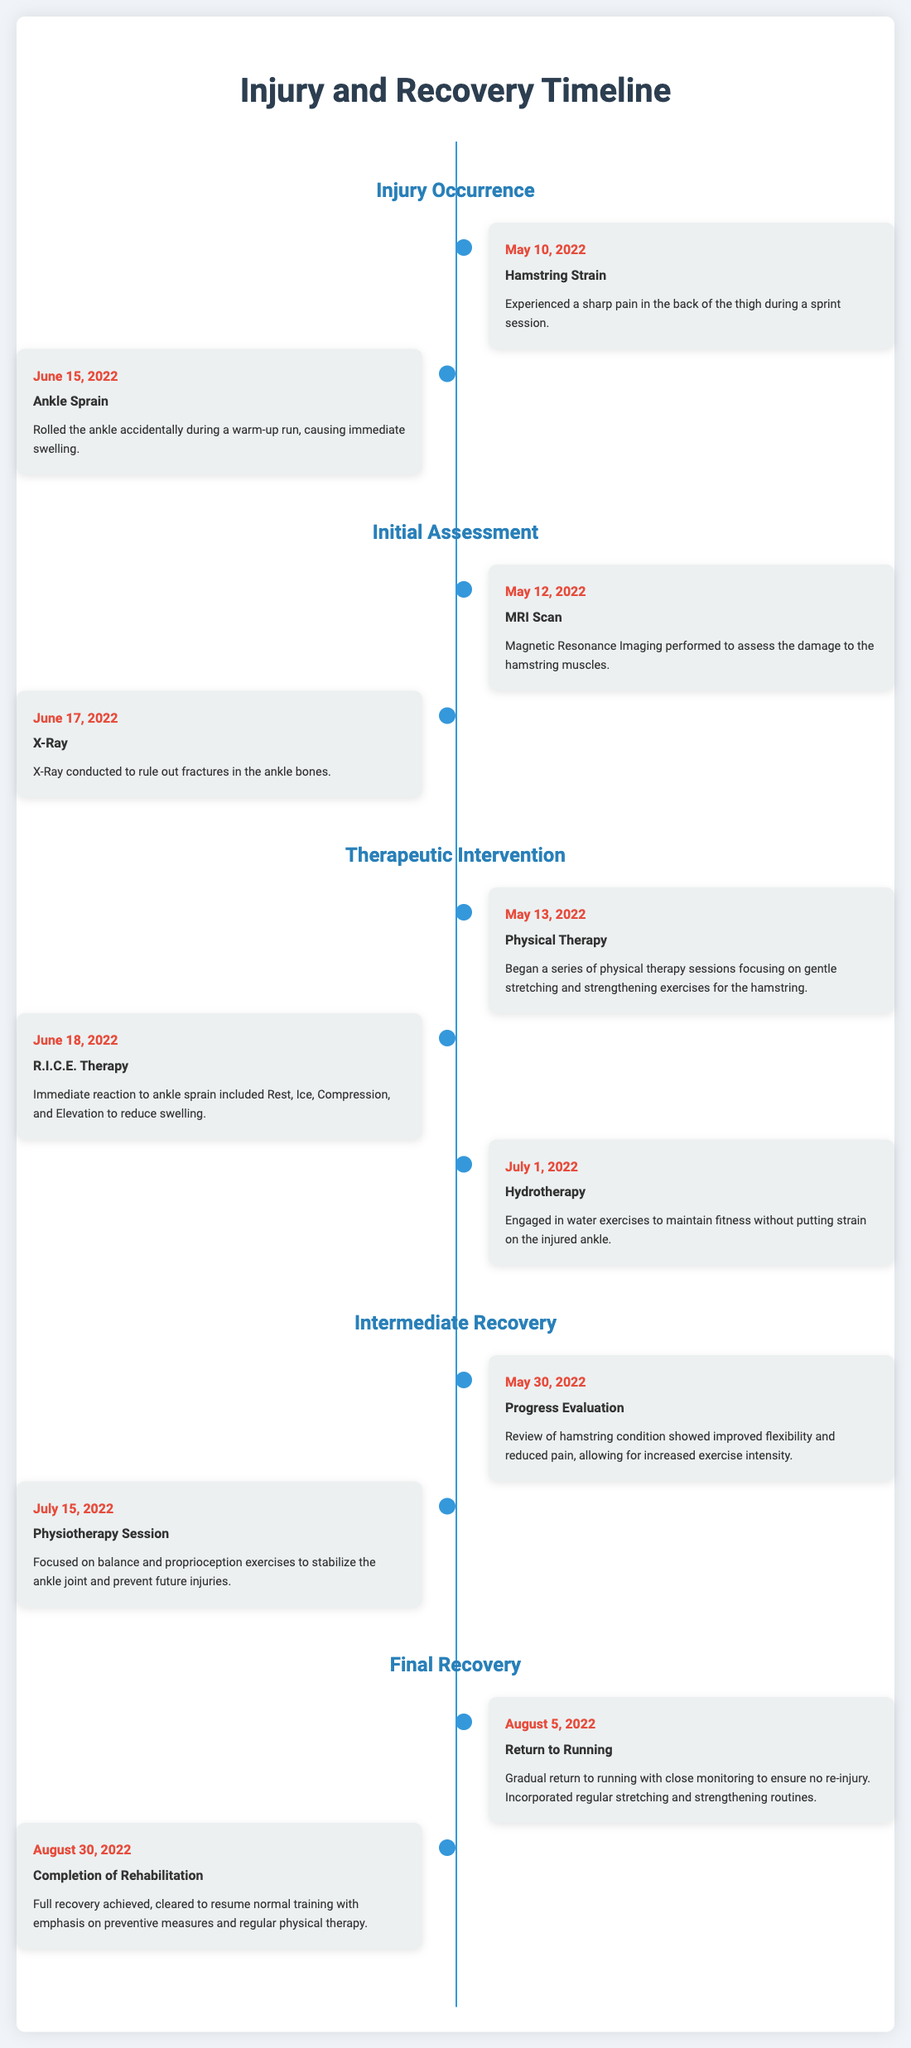What injury occurred on May 10, 2022? The document states that a hamstring strain occurred on this date.
Answer: Hamstring Strain What type of therapy was initiated on May 13, 2022? The document mentions that physical therapy began on this date.
Answer: Physical Therapy What was performed on June 17, 2022? The document indicates that an X-Ray was conducted on this date.
Answer: X-Ray What was the outcome of the progress evaluation on May 30, 2022? The document notes improved flexibility and reduced pain in the hamstring condition.
Answer: Improved flexibility and reduced pain How many days between the ankle sprain and the MRI scan? The document shows the ankle sprain occurred on June 15, 2022, and the MRI scan on May 12, 2022, indicating a total of 34 days in between.
Answer: 34 days What rehabilitation phase includes the return to running? The document categorizes the return to running under the final recovery phase.
Answer: Final Recovery What type of exercises were focused on in the physiotherapy session on July 15, 2022? The document describes that balance and proprioception exercises were the focus during this session.
Answer: Balance and proprioception exercises On what date was the rehabilitation completed? The document states that rehabilitation was completed on August 30, 2022.
Answer: August 30, 2022 What does R.I.C.E. stand for? The document explains that R.I.C.E. stands for Rest, Ice, Compression, and Elevation.
Answer: Rest, Ice, Compression, and Elevation 